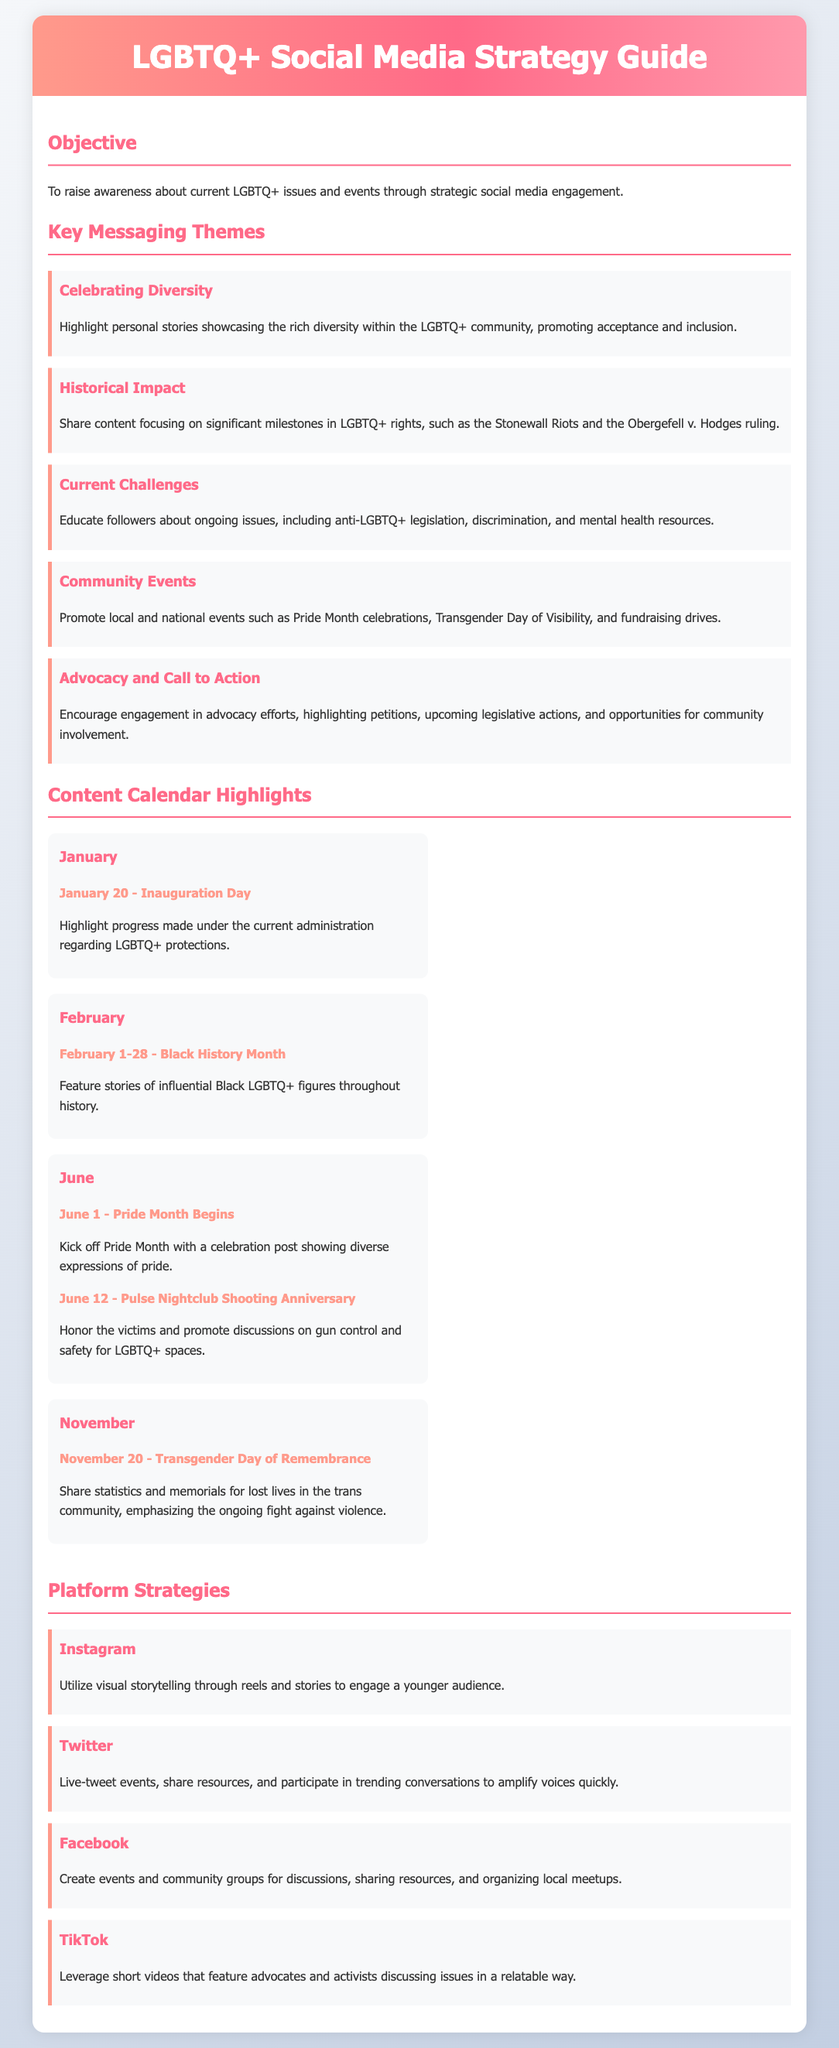what is the objective of the document? The document aims to raise awareness about current LGBTQ+ issues and events through strategic social media engagement.
Answer: To raise awareness about current LGBTQ+ issues and events how many key messaging themes are listed? The document specifies five key messaging themes that guide the social media strategy.
Answer: 5 which month marks the beginning of Pride Month? The document states that Pride Month begins on June 1, which is a significant event for the LGBTQ+ community.
Answer: June 1 what significant event is commemorated on November 20? The document indicates that November 20 is designated as Transgender Day of Remembrance, which serves to honor the lives lost in the trans community.
Answer: Transgender Day of Remembrance what platform is recommended for visual storytelling? The document suggests using Instagram for visual storytelling to engage a younger audience.
Answer: Instagram how does the document suggest using Twitter? The strategy includes live-tweeting events, sharing resources, and participating in trending conversations to amplify voices quickly.
Answer: Live-tweet events what theme focuses on ongoing issues faced by the LGBTQ+ community? The theme titled "Current Challenges" addresses the ongoing issues, which include anti-LGBTQ+ legislation and discrimination.
Answer: Current Challenges which holiday is highlighted on January 20? The document highlights Inauguration Day, emphasizing the progress made in LGBTQ+ protections under the current administration.
Answer: Inauguration Day which month features Black History Month activities? The document specifies February as the month for Black History Month, featuring influential Black LGBTQ+ figures.
Answer: February 